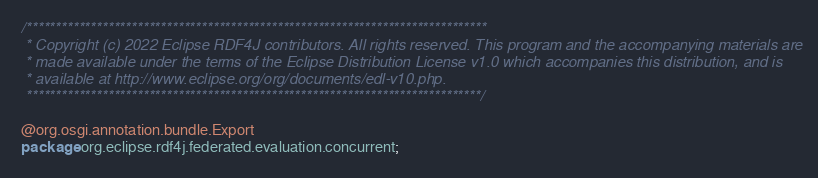Convert code to text. <code><loc_0><loc_0><loc_500><loc_500><_Java_>/*******************************************************************************
 * Copyright (c) 2022 Eclipse RDF4J contributors. All rights reserved. This program and the accompanying materials are
 * made available under the terms of the Eclipse Distribution License v1.0 which accompanies this distribution, and is
 * available at http://www.eclipse.org/org/documents/edl-v10.php.
 ******************************************************************************/

@org.osgi.annotation.bundle.Export
package org.eclipse.rdf4j.federated.evaluation.concurrent;</code> 